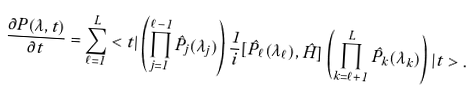Convert formula to latex. <formula><loc_0><loc_0><loc_500><loc_500>\frac { \partial P ( { \lambda } , t ) } { \partial t } = \sum _ { \ell = 1 } ^ { L } < t | \left ( \prod _ { j = 1 } ^ { \ell - 1 } { \hat { P } } _ { j } ( \lambda _ { j } ) \right ) \frac { 1 } { i } [ { \hat { P } } _ { \ell } ( \lambda _ { \ell } ) , { \hat { H } } ] \left ( \prod _ { k = \ell + 1 } ^ { L } { \hat { P } } _ { k } ( \lambda _ { k } ) \right ) | t > .</formula> 